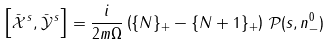Convert formula to latex. <formula><loc_0><loc_0><loc_500><loc_500>\left [ \bar { \mathcal { X } } ^ { \, s } , \bar { \mathcal { Y } } ^ { \, s } \right ] = \frac { i } { 2 m \Omega } \left ( \{ N \} _ { + } - \{ N + 1 \} _ { + } \right ) \, { \mathcal { P } } ( s , n ^ { 0 } _ { - } )</formula> 